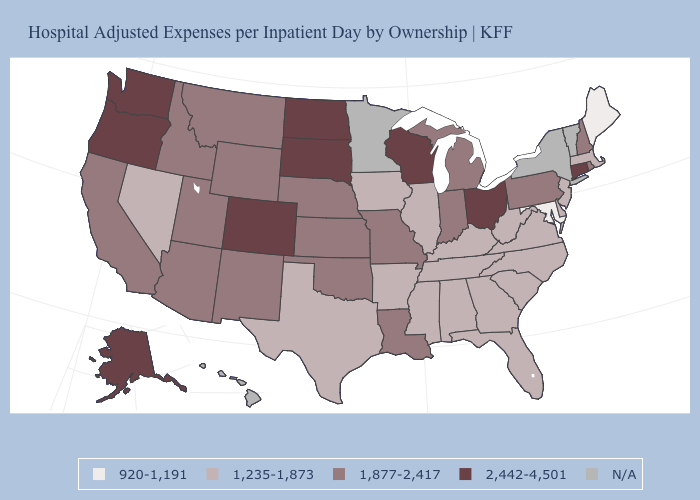What is the value of Virginia?
Concise answer only. 1,235-1,873. Name the states that have a value in the range 920-1,191?
Give a very brief answer. Maine, Maryland. What is the value of Illinois?
Keep it brief. 1,235-1,873. What is the highest value in the USA?
Write a very short answer. 2,442-4,501. Name the states that have a value in the range N/A?
Be succinct. Hawaii, Minnesota, New York, Vermont. Among the states that border Oregon , does Nevada have the lowest value?
Keep it brief. Yes. Which states hav the highest value in the West?
Concise answer only. Alaska, Colorado, Oregon, Washington. What is the value of Maine?
Write a very short answer. 920-1,191. Name the states that have a value in the range 920-1,191?
Short answer required. Maine, Maryland. What is the lowest value in the Northeast?
Give a very brief answer. 920-1,191. Name the states that have a value in the range 920-1,191?
Quick response, please. Maine, Maryland. What is the lowest value in the West?
Be succinct. 1,235-1,873. What is the lowest value in the USA?
Keep it brief. 920-1,191. 